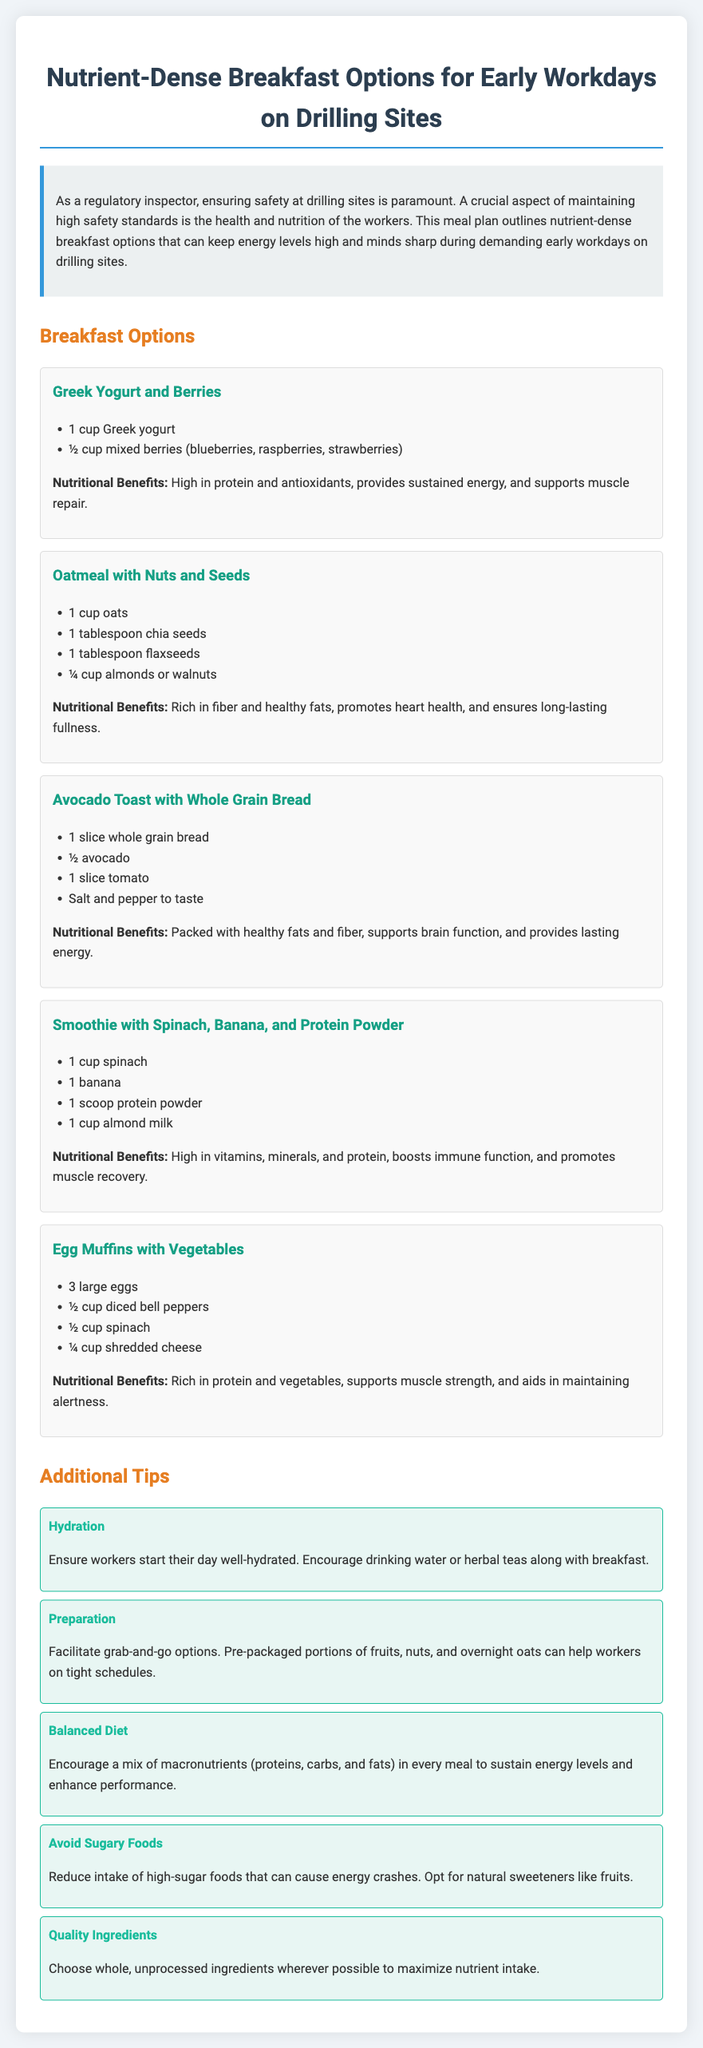What is the first breakfast option listed? The first breakfast option is the Greek Yogurt and Berries meal.
Answer: Greek Yogurt and Berries How many ingredients are listed for Oatmeal with Nuts and Seeds? The ingredients for Oatmeal with Nuts and Seeds include four items: oats, chia seeds, flaxseeds, and nuts.
Answer: 4 What is a nutritional benefit of Avocado Toast? The Avocado Toast is packed with healthy fats and fiber as a nutritional benefit.
Answer: Packed with healthy fats and fiber What is recommended to ensure workers start their day well? The document suggests ensuring workers start their day well-hydrated.
Answer: Well-hydrated How many large eggs are used in Egg Muffins? The recipe for Egg Muffins includes three large eggs.
Answer: 3 What is mentioned as an alternative to high-sugar foods? The document advises opting for natural sweeteners like fruits.
Answer: Natural sweeteners like fruits What meal is recommended for muscle recovery? The Smoothie with Spinach, Banana, and Protein Powder is recommended for muscle recovery.
Answer: Smoothie with Spinach, Banana, and Protein Powder What is a tip for meal preparation? The document advises facilitating grab-and-go options for meal preparation.
Answer: Grab-and-go options How many breakfast options are provided in total? There are five breakfast options listed in the document.
Answer: 5 